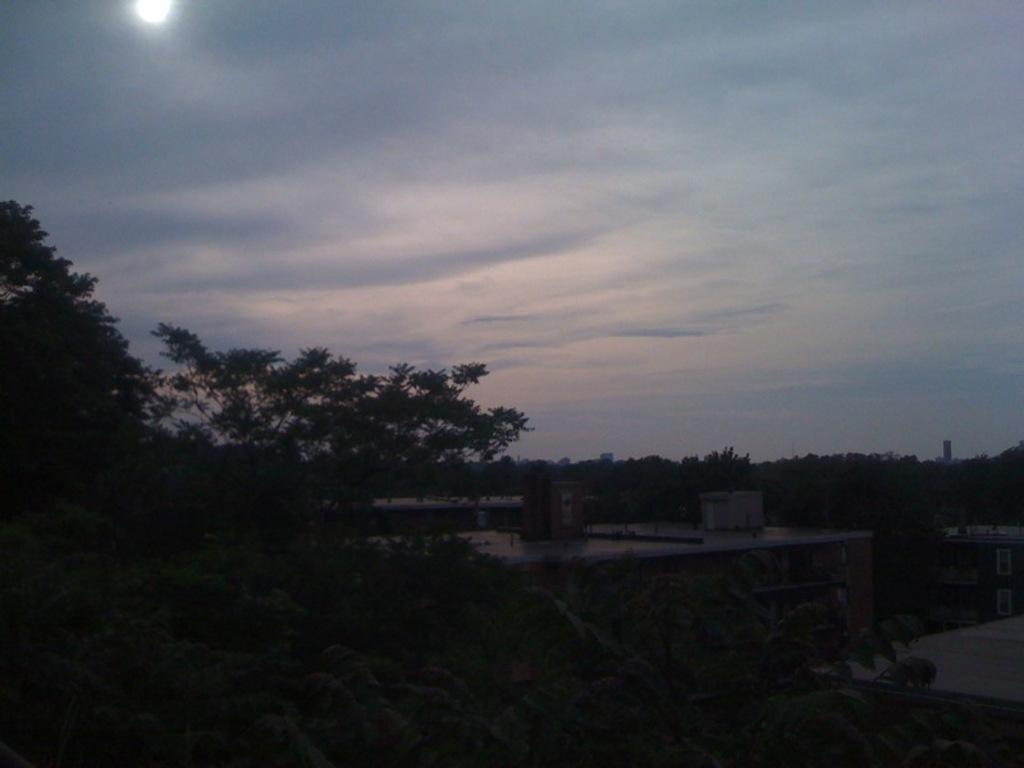What type of structures can be seen in the image? There are buildings in the image. What other natural elements are present in the image? There are trees in the image. Can you describe any other objects visible in the image? There are other objects in the image, but their specific details are not mentioned in the provided facts. What is visible at the top of the image? The sky is visible at the top of the image. What celestial body can be seen in the sky? The sun is observable in the sky. How many crows are sitting on the tail of the airplane in the image? There is no airplane or crow present in the image; it features buildings, trees, and other objects. 